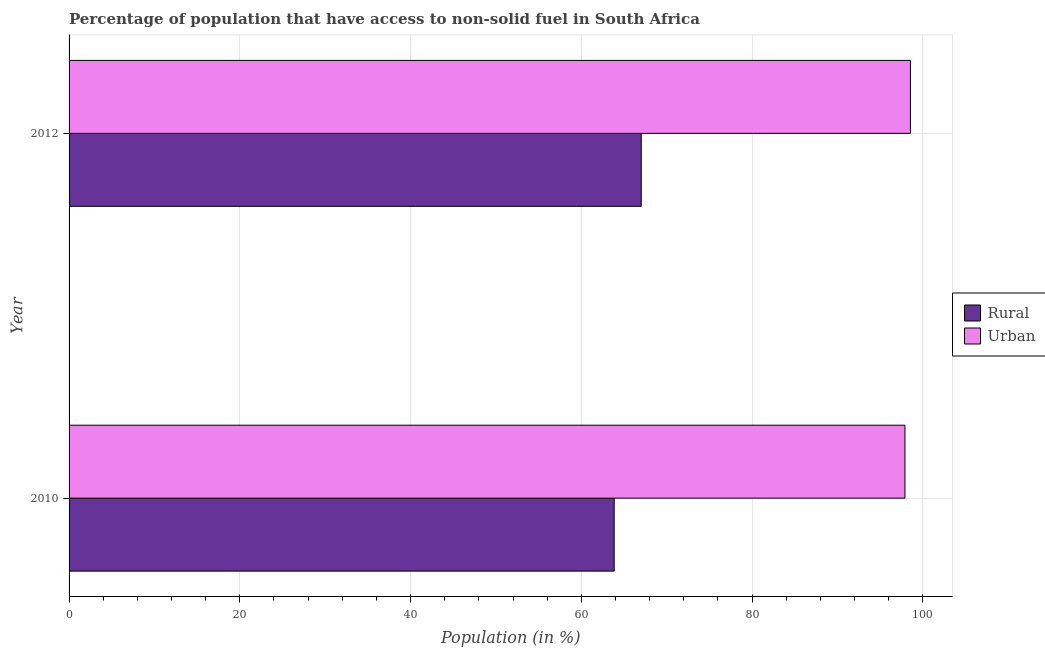How many different coloured bars are there?
Offer a very short reply. 2. Are the number of bars per tick equal to the number of legend labels?
Your answer should be very brief. Yes. Are the number of bars on each tick of the Y-axis equal?
Keep it short and to the point. Yes. How many bars are there on the 1st tick from the top?
Give a very brief answer. 2. What is the label of the 1st group of bars from the top?
Ensure brevity in your answer.  2012. What is the urban population in 2010?
Give a very brief answer. 97.9. Across all years, what is the maximum urban population?
Give a very brief answer. 98.54. Across all years, what is the minimum urban population?
Offer a terse response. 97.9. In which year was the urban population minimum?
Make the answer very short. 2010. What is the total urban population in the graph?
Make the answer very short. 196.44. What is the difference between the rural population in 2010 and that in 2012?
Your response must be concise. -3.17. What is the difference between the rural population in 2010 and the urban population in 2012?
Keep it short and to the point. -34.7. What is the average urban population per year?
Ensure brevity in your answer.  98.22. In the year 2012, what is the difference between the rural population and urban population?
Provide a succinct answer. -31.53. In how many years, is the rural population greater than 12 %?
Your answer should be compact. 2. What does the 1st bar from the top in 2010 represents?
Give a very brief answer. Urban. What does the 1st bar from the bottom in 2012 represents?
Offer a very short reply. Rural. How many bars are there?
Keep it short and to the point. 4. Are all the bars in the graph horizontal?
Offer a terse response. Yes. How many years are there in the graph?
Offer a terse response. 2. Are the values on the major ticks of X-axis written in scientific E-notation?
Offer a terse response. No. Where does the legend appear in the graph?
Offer a very short reply. Center right. How many legend labels are there?
Provide a succinct answer. 2. What is the title of the graph?
Provide a succinct answer. Percentage of population that have access to non-solid fuel in South Africa. What is the Population (in %) of Rural in 2010?
Provide a succinct answer. 63.84. What is the Population (in %) of Urban in 2010?
Provide a succinct answer. 97.9. What is the Population (in %) in Rural in 2012?
Offer a terse response. 67.01. What is the Population (in %) in Urban in 2012?
Your response must be concise. 98.54. Across all years, what is the maximum Population (in %) of Rural?
Provide a short and direct response. 67.01. Across all years, what is the maximum Population (in %) in Urban?
Offer a very short reply. 98.54. Across all years, what is the minimum Population (in %) of Rural?
Offer a terse response. 63.84. Across all years, what is the minimum Population (in %) in Urban?
Your answer should be compact. 97.9. What is the total Population (in %) of Rural in the graph?
Make the answer very short. 130.86. What is the total Population (in %) of Urban in the graph?
Your response must be concise. 196.44. What is the difference between the Population (in %) in Rural in 2010 and that in 2012?
Your response must be concise. -3.17. What is the difference between the Population (in %) of Urban in 2010 and that in 2012?
Your response must be concise. -0.65. What is the difference between the Population (in %) of Rural in 2010 and the Population (in %) of Urban in 2012?
Make the answer very short. -34.7. What is the average Population (in %) of Rural per year?
Ensure brevity in your answer.  65.43. What is the average Population (in %) in Urban per year?
Ensure brevity in your answer.  98.22. In the year 2010, what is the difference between the Population (in %) in Rural and Population (in %) in Urban?
Offer a terse response. -34.05. In the year 2012, what is the difference between the Population (in %) of Rural and Population (in %) of Urban?
Offer a terse response. -31.53. What is the ratio of the Population (in %) of Rural in 2010 to that in 2012?
Your response must be concise. 0.95. What is the difference between the highest and the second highest Population (in %) in Rural?
Keep it short and to the point. 3.17. What is the difference between the highest and the second highest Population (in %) in Urban?
Offer a terse response. 0.65. What is the difference between the highest and the lowest Population (in %) in Rural?
Your answer should be very brief. 3.17. What is the difference between the highest and the lowest Population (in %) of Urban?
Ensure brevity in your answer.  0.65. 